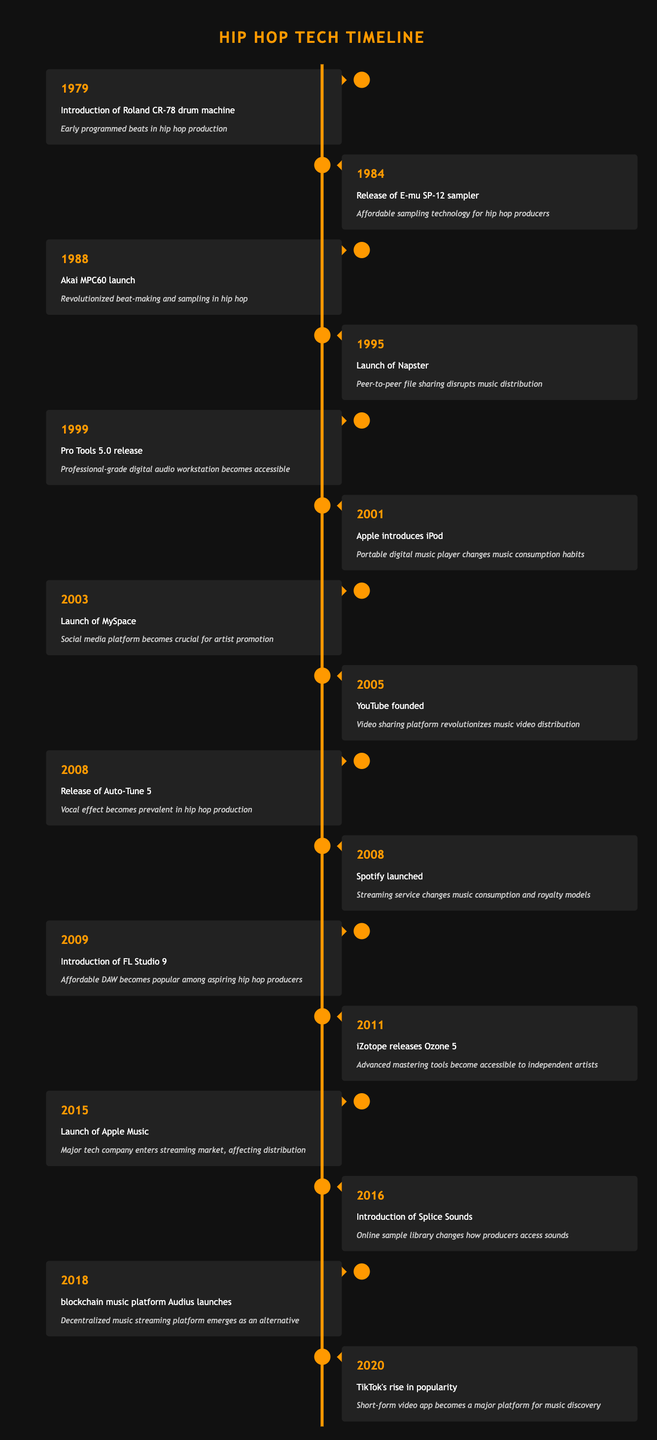What was the first major technological advancement in hip hop music production? The table indicates that the first major technological advancement listed is the introduction of the Roland CR-78 drum machine in 1979.
Answer: Roland CR-78 drum machine Which event in the timeline had the most impact on music distribution? The launch of Napster in 1995 is noted as disrupting music distribution through peer-to-peer file sharing, which was a crucial change in how music was distributed.
Answer: Launch of Napster How many events occurred in the 2000s? By counting the entries from 2001 to 2019, there are eight events listed from the years 2001 to 2009 (including two events in 2008), making a total of eight events in the 2000s.
Answer: 8 events Was the iPod's introduction in 2001 a significant event for hip hop music consumption? Yes, the introduction of the iPod is described as changing music consumption habits, indicating its significance in the context of hip hop music.
Answer: Yes What is the average year of the events listed? The earliest event is from 1979 and the latest from 2020. To find the average, you sum the years (1979 + 1984 + 1988 + 1995 + 1999 + 2001 + 2003 + 2005 + 2008 + 2008 + 2009 + 2011 + 2015 + 2016 + 2018 + 2020 =  30796) and divide by the number of events (16). Hence, average = 30796/16 = 1924.75.
Answer: 1924.75 What two major platforms were launched in 2005? According to the timeline, YouTube and MySpace were both significant platforms launched in 2005, thus marking a revolutionary change in music promotion and distribution.
Answer: YouTube and MySpace When did streaming services like Spotify and Apple Music start to impact hip hop music? Streaming services began impacting hip hop music in 2008 with Spotify's launch and were further solidified with Apple Music's launch in 2015.
Answer: 2008 and 2015 Did the Akai MPC60 launch affect beat-making and sampling in hip hop music? Yes, the Akai MPC60 launch in 1988 is noted as having revolutionized beat-making and sampling, confirming its significant impact on hip hop music.
Answer: Yes 